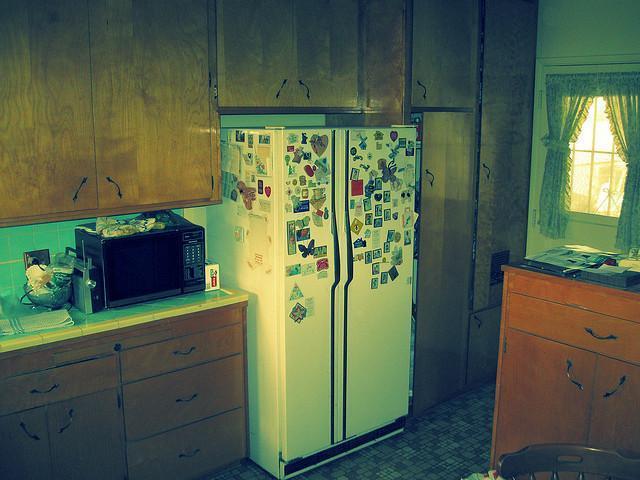How many forks are visible?
Give a very brief answer. 0. How many pans sit atop the stove?
Give a very brief answer. 0. How many refrigerators are in the photo?
Give a very brief answer. 1. How many people will eat on these plates?
Give a very brief answer. 0. 